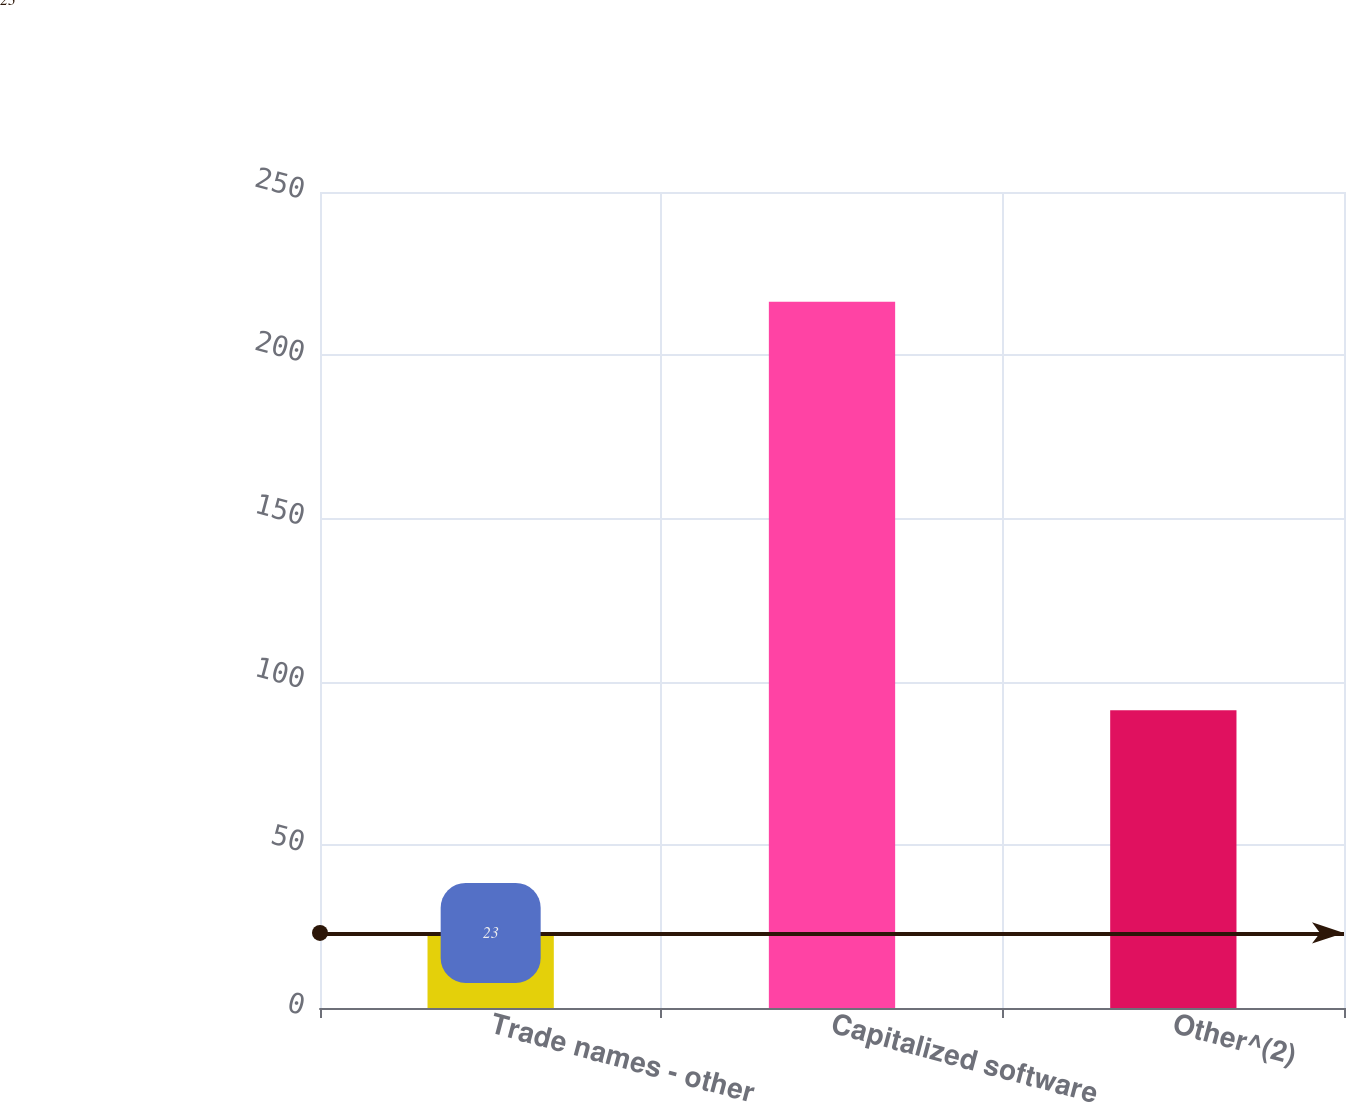Convert chart to OTSL. <chart><loc_0><loc_0><loc_500><loc_500><bar_chart><fcel>Trade names - other<fcel>Capitalized software<fcel>Other^(2)<nl><fcel>23<fcel>216.4<fcel>91.2<nl></chart> 